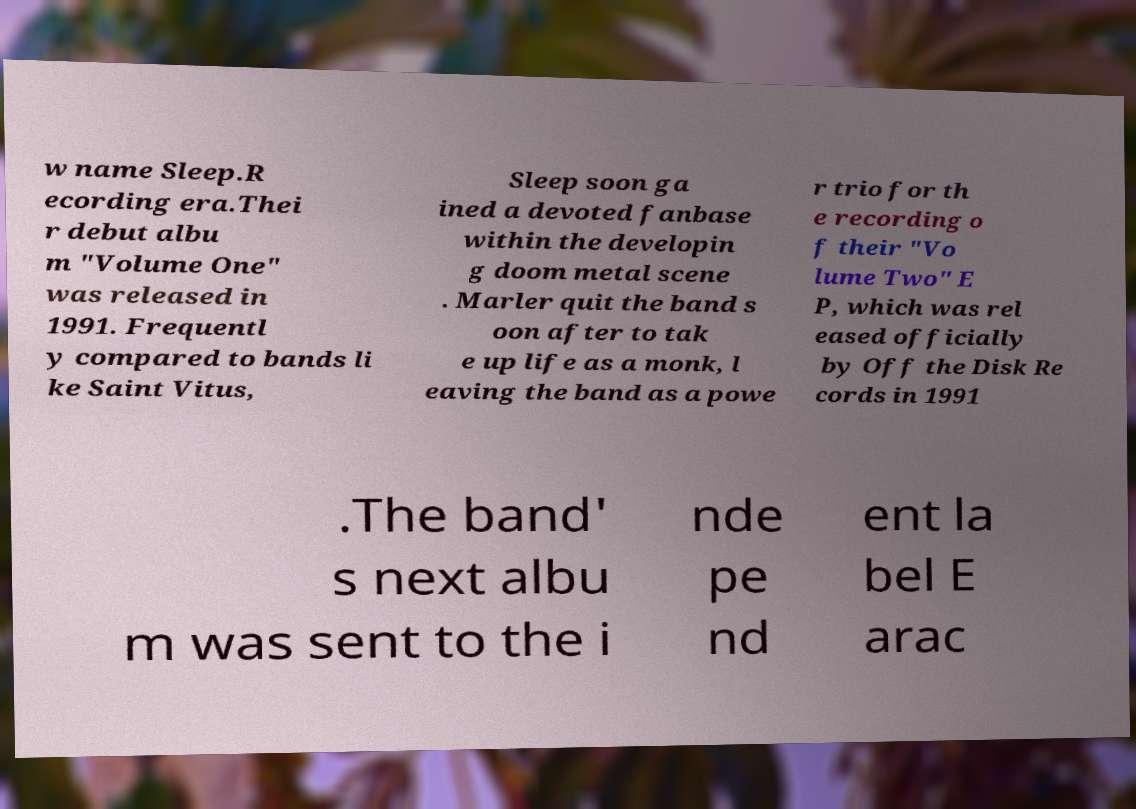For documentation purposes, I need the text within this image transcribed. Could you provide that? w name Sleep.R ecording era.Thei r debut albu m "Volume One" was released in 1991. Frequentl y compared to bands li ke Saint Vitus, Sleep soon ga ined a devoted fanbase within the developin g doom metal scene . Marler quit the band s oon after to tak e up life as a monk, l eaving the band as a powe r trio for th e recording o f their "Vo lume Two" E P, which was rel eased officially by Off the Disk Re cords in 1991 .The band' s next albu m was sent to the i nde pe nd ent la bel E arac 